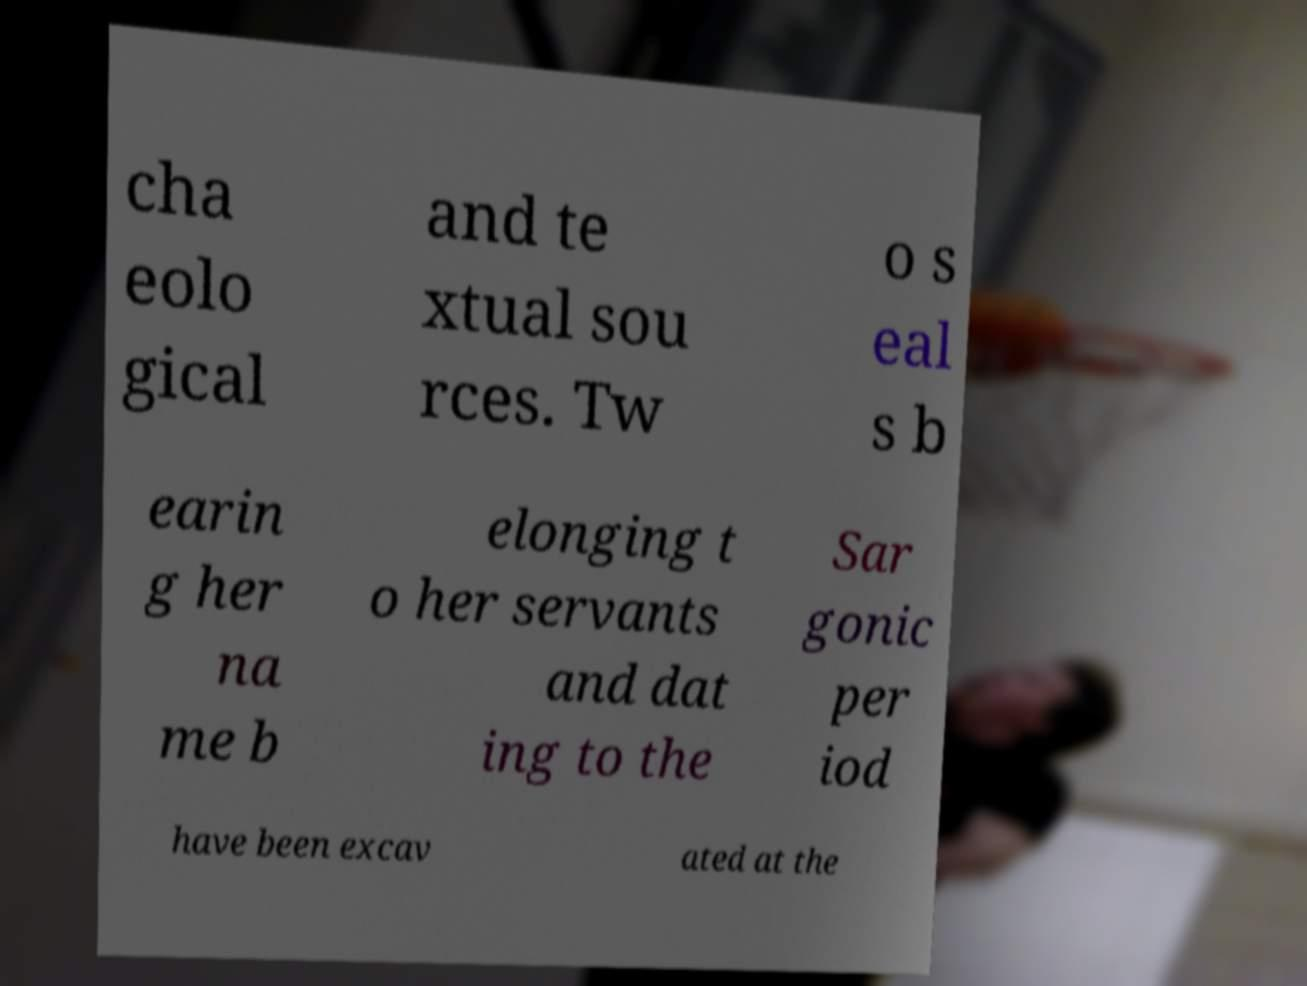I need the written content from this picture converted into text. Can you do that? cha eolo gical and te xtual sou rces. Tw o s eal s b earin g her na me b elonging t o her servants and dat ing to the Sar gonic per iod have been excav ated at the 